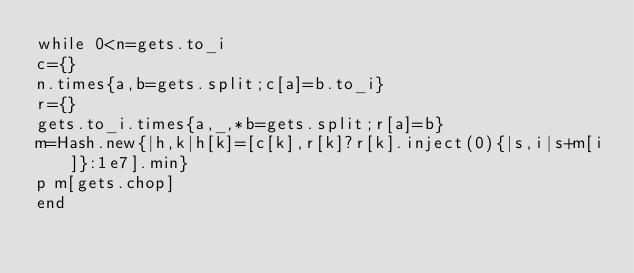Convert code to text. <code><loc_0><loc_0><loc_500><loc_500><_Ruby_>while 0<n=gets.to_i
c={}
n.times{a,b=gets.split;c[a]=b.to_i}
r={}
gets.to_i.times{a,_,*b=gets.split;r[a]=b}
m=Hash.new{|h,k|h[k]=[c[k],r[k]?r[k].inject(0){|s,i|s+m[i]}:1e7].min}
p m[gets.chop]
end</code> 